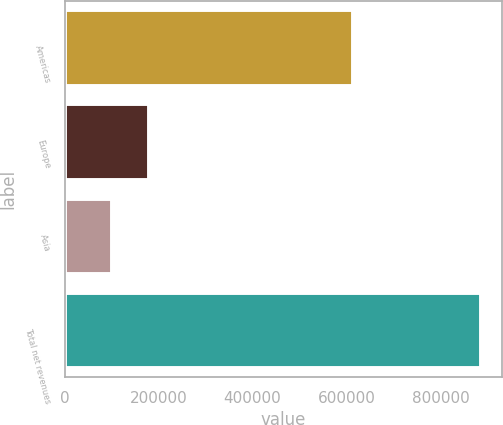<chart> <loc_0><loc_0><loc_500><loc_500><bar_chart><fcel>Americas<fcel>Europe<fcel>Asia<fcel>Total net revenues<nl><fcel>613819<fcel>180110<fcel>101564<fcel>887022<nl></chart> 